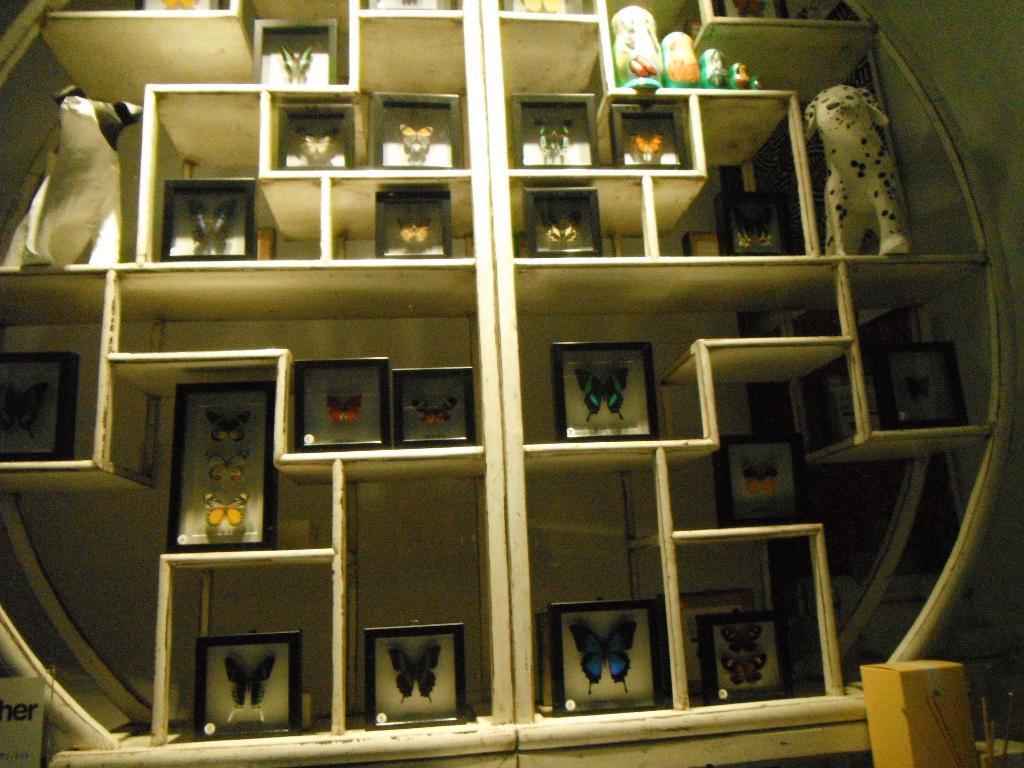Could you give a brief overview of what you see in this image? In this image I can see number of frames, few white colour things and few other things on these shares. I can also see a board, a yellow colour box and on this board I can see something is written. 